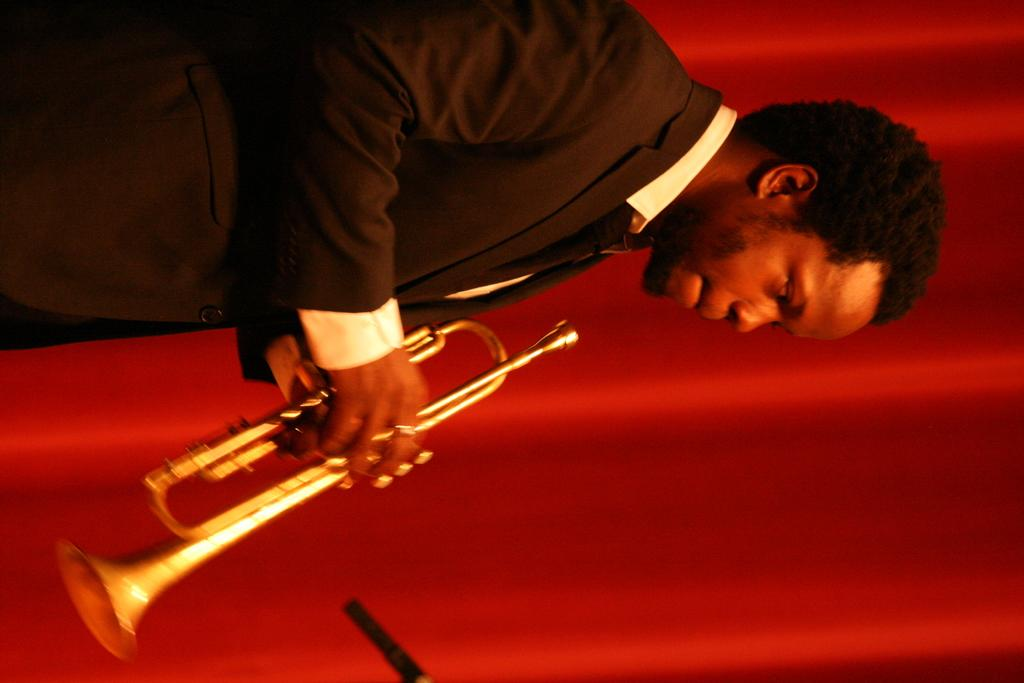What is the main subject of the image? There is a person in the image. What is the person wearing? The person is wearing a black suit. What object is the person holding? The person is holding a trumpet. What color is the wall in the background of the image? There is a red wall in the background of the image. Is the person swimming in the image? No, the person is not swimming in the image; they are standing and holding a trumpet. How many bricks can be seen in the image? There is no mention of bricks in the image; the background wall is described as red. 